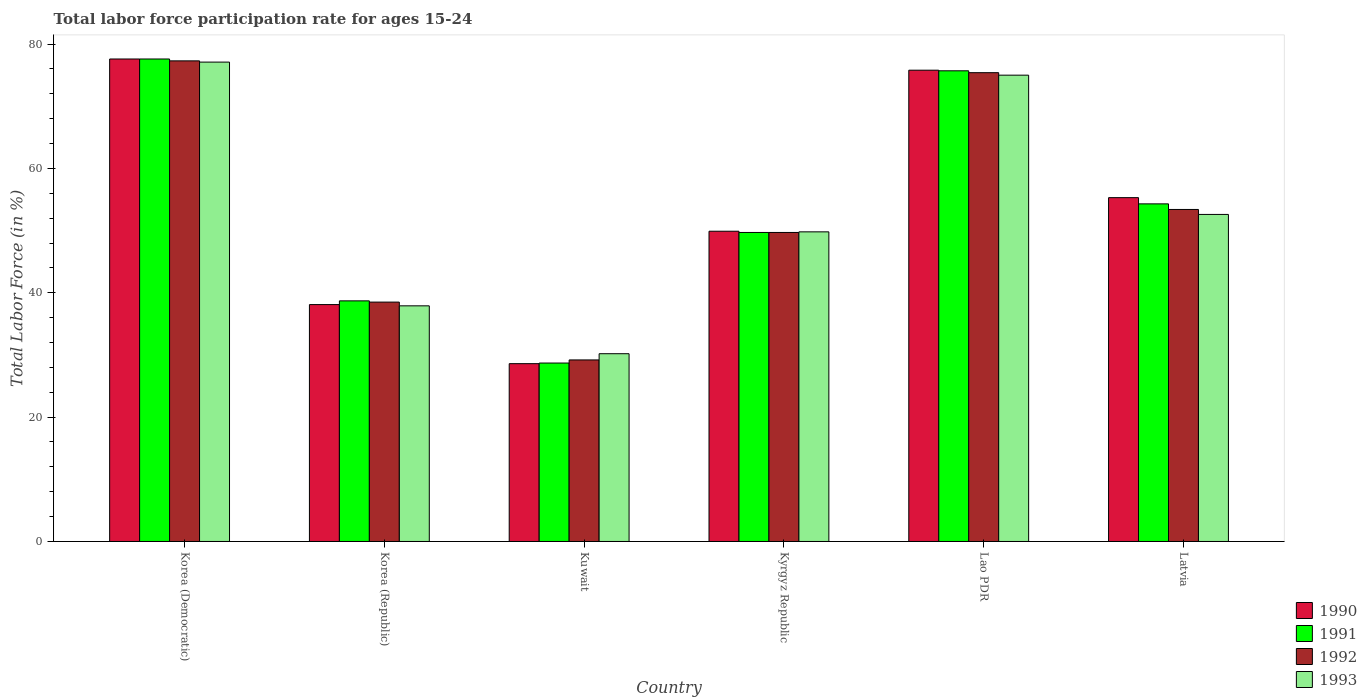How many different coloured bars are there?
Ensure brevity in your answer.  4. How many groups of bars are there?
Provide a succinct answer. 6. What is the label of the 5th group of bars from the left?
Give a very brief answer. Lao PDR. In how many cases, is the number of bars for a given country not equal to the number of legend labels?
Offer a very short reply. 0. What is the labor force participation rate in 1993 in Kuwait?
Give a very brief answer. 30.2. Across all countries, what is the maximum labor force participation rate in 1991?
Offer a very short reply. 77.6. Across all countries, what is the minimum labor force participation rate in 1991?
Provide a short and direct response. 28.7. In which country was the labor force participation rate in 1993 maximum?
Ensure brevity in your answer.  Korea (Democratic). In which country was the labor force participation rate in 1990 minimum?
Your answer should be very brief. Kuwait. What is the total labor force participation rate in 1992 in the graph?
Offer a very short reply. 323.5. What is the difference between the labor force participation rate in 1990 in Kuwait and that in Kyrgyz Republic?
Offer a terse response. -21.3. What is the average labor force participation rate in 1992 per country?
Make the answer very short. 53.92. What is the difference between the labor force participation rate of/in 1993 and labor force participation rate of/in 1991 in Kyrgyz Republic?
Your answer should be very brief. 0.1. In how many countries, is the labor force participation rate in 1993 greater than 20 %?
Keep it short and to the point. 6. What is the ratio of the labor force participation rate in 1991 in Korea (Republic) to that in Latvia?
Make the answer very short. 0.71. What is the difference between the highest and the second highest labor force participation rate in 1992?
Make the answer very short. -22. What is the difference between the highest and the lowest labor force participation rate in 1990?
Your answer should be very brief. 49. In how many countries, is the labor force participation rate in 1990 greater than the average labor force participation rate in 1990 taken over all countries?
Your answer should be compact. 3. Is it the case that in every country, the sum of the labor force participation rate in 1993 and labor force participation rate in 1992 is greater than the sum of labor force participation rate in 1991 and labor force participation rate in 1990?
Offer a terse response. No. What does the 4th bar from the right in Kuwait represents?
Offer a terse response. 1990. How many bars are there?
Your response must be concise. 24. How many countries are there in the graph?
Your response must be concise. 6. Are the values on the major ticks of Y-axis written in scientific E-notation?
Your answer should be compact. No. How many legend labels are there?
Give a very brief answer. 4. How are the legend labels stacked?
Provide a short and direct response. Vertical. What is the title of the graph?
Offer a very short reply. Total labor force participation rate for ages 15-24. Does "1967" appear as one of the legend labels in the graph?
Your answer should be compact. No. What is the label or title of the Y-axis?
Provide a short and direct response. Total Labor Force (in %). What is the Total Labor Force (in %) of 1990 in Korea (Democratic)?
Your response must be concise. 77.6. What is the Total Labor Force (in %) in 1991 in Korea (Democratic)?
Offer a terse response. 77.6. What is the Total Labor Force (in %) of 1992 in Korea (Democratic)?
Offer a very short reply. 77.3. What is the Total Labor Force (in %) in 1993 in Korea (Democratic)?
Ensure brevity in your answer.  77.1. What is the Total Labor Force (in %) of 1990 in Korea (Republic)?
Ensure brevity in your answer.  38.1. What is the Total Labor Force (in %) of 1991 in Korea (Republic)?
Your response must be concise. 38.7. What is the Total Labor Force (in %) of 1992 in Korea (Republic)?
Offer a terse response. 38.5. What is the Total Labor Force (in %) in 1993 in Korea (Republic)?
Offer a very short reply. 37.9. What is the Total Labor Force (in %) of 1990 in Kuwait?
Make the answer very short. 28.6. What is the Total Labor Force (in %) of 1991 in Kuwait?
Your answer should be very brief. 28.7. What is the Total Labor Force (in %) of 1992 in Kuwait?
Offer a terse response. 29.2. What is the Total Labor Force (in %) of 1993 in Kuwait?
Offer a terse response. 30.2. What is the Total Labor Force (in %) of 1990 in Kyrgyz Republic?
Your answer should be compact. 49.9. What is the Total Labor Force (in %) of 1991 in Kyrgyz Republic?
Your answer should be compact. 49.7. What is the Total Labor Force (in %) of 1992 in Kyrgyz Republic?
Provide a short and direct response. 49.7. What is the Total Labor Force (in %) in 1993 in Kyrgyz Republic?
Offer a terse response. 49.8. What is the Total Labor Force (in %) in 1990 in Lao PDR?
Your answer should be compact. 75.8. What is the Total Labor Force (in %) in 1991 in Lao PDR?
Give a very brief answer. 75.7. What is the Total Labor Force (in %) of 1992 in Lao PDR?
Offer a terse response. 75.4. What is the Total Labor Force (in %) of 1990 in Latvia?
Provide a short and direct response. 55.3. What is the Total Labor Force (in %) of 1991 in Latvia?
Make the answer very short. 54.3. What is the Total Labor Force (in %) of 1992 in Latvia?
Ensure brevity in your answer.  53.4. What is the Total Labor Force (in %) in 1993 in Latvia?
Your answer should be very brief. 52.6. Across all countries, what is the maximum Total Labor Force (in %) of 1990?
Your answer should be compact. 77.6. Across all countries, what is the maximum Total Labor Force (in %) in 1991?
Ensure brevity in your answer.  77.6. Across all countries, what is the maximum Total Labor Force (in %) in 1992?
Keep it short and to the point. 77.3. Across all countries, what is the maximum Total Labor Force (in %) in 1993?
Give a very brief answer. 77.1. Across all countries, what is the minimum Total Labor Force (in %) in 1990?
Your answer should be compact. 28.6. Across all countries, what is the minimum Total Labor Force (in %) of 1991?
Ensure brevity in your answer.  28.7. Across all countries, what is the minimum Total Labor Force (in %) of 1992?
Provide a short and direct response. 29.2. Across all countries, what is the minimum Total Labor Force (in %) in 1993?
Ensure brevity in your answer.  30.2. What is the total Total Labor Force (in %) in 1990 in the graph?
Your answer should be compact. 325.3. What is the total Total Labor Force (in %) of 1991 in the graph?
Make the answer very short. 324.7. What is the total Total Labor Force (in %) of 1992 in the graph?
Offer a terse response. 323.5. What is the total Total Labor Force (in %) of 1993 in the graph?
Provide a short and direct response. 322.6. What is the difference between the Total Labor Force (in %) of 1990 in Korea (Democratic) and that in Korea (Republic)?
Your answer should be compact. 39.5. What is the difference between the Total Labor Force (in %) in 1991 in Korea (Democratic) and that in Korea (Republic)?
Offer a terse response. 38.9. What is the difference between the Total Labor Force (in %) of 1992 in Korea (Democratic) and that in Korea (Republic)?
Your answer should be compact. 38.8. What is the difference between the Total Labor Force (in %) in 1993 in Korea (Democratic) and that in Korea (Republic)?
Provide a succinct answer. 39.2. What is the difference between the Total Labor Force (in %) in 1990 in Korea (Democratic) and that in Kuwait?
Your answer should be compact. 49. What is the difference between the Total Labor Force (in %) in 1991 in Korea (Democratic) and that in Kuwait?
Offer a terse response. 48.9. What is the difference between the Total Labor Force (in %) in 1992 in Korea (Democratic) and that in Kuwait?
Your answer should be very brief. 48.1. What is the difference between the Total Labor Force (in %) in 1993 in Korea (Democratic) and that in Kuwait?
Your answer should be very brief. 46.9. What is the difference between the Total Labor Force (in %) of 1990 in Korea (Democratic) and that in Kyrgyz Republic?
Make the answer very short. 27.7. What is the difference between the Total Labor Force (in %) in 1991 in Korea (Democratic) and that in Kyrgyz Republic?
Provide a succinct answer. 27.9. What is the difference between the Total Labor Force (in %) in 1992 in Korea (Democratic) and that in Kyrgyz Republic?
Offer a very short reply. 27.6. What is the difference between the Total Labor Force (in %) of 1993 in Korea (Democratic) and that in Kyrgyz Republic?
Provide a succinct answer. 27.3. What is the difference between the Total Labor Force (in %) of 1990 in Korea (Democratic) and that in Lao PDR?
Make the answer very short. 1.8. What is the difference between the Total Labor Force (in %) in 1992 in Korea (Democratic) and that in Lao PDR?
Offer a very short reply. 1.9. What is the difference between the Total Labor Force (in %) in 1993 in Korea (Democratic) and that in Lao PDR?
Ensure brevity in your answer.  2.1. What is the difference between the Total Labor Force (in %) of 1990 in Korea (Democratic) and that in Latvia?
Keep it short and to the point. 22.3. What is the difference between the Total Labor Force (in %) of 1991 in Korea (Democratic) and that in Latvia?
Your answer should be compact. 23.3. What is the difference between the Total Labor Force (in %) of 1992 in Korea (Democratic) and that in Latvia?
Your answer should be compact. 23.9. What is the difference between the Total Labor Force (in %) in 1992 in Korea (Republic) and that in Kuwait?
Provide a short and direct response. 9.3. What is the difference between the Total Labor Force (in %) in 1991 in Korea (Republic) and that in Kyrgyz Republic?
Your response must be concise. -11. What is the difference between the Total Labor Force (in %) in 1990 in Korea (Republic) and that in Lao PDR?
Provide a succinct answer. -37.7. What is the difference between the Total Labor Force (in %) in 1991 in Korea (Republic) and that in Lao PDR?
Your response must be concise. -37. What is the difference between the Total Labor Force (in %) of 1992 in Korea (Republic) and that in Lao PDR?
Keep it short and to the point. -36.9. What is the difference between the Total Labor Force (in %) of 1993 in Korea (Republic) and that in Lao PDR?
Your answer should be compact. -37.1. What is the difference between the Total Labor Force (in %) in 1990 in Korea (Republic) and that in Latvia?
Ensure brevity in your answer.  -17.2. What is the difference between the Total Labor Force (in %) of 1991 in Korea (Republic) and that in Latvia?
Offer a terse response. -15.6. What is the difference between the Total Labor Force (in %) in 1992 in Korea (Republic) and that in Latvia?
Ensure brevity in your answer.  -14.9. What is the difference between the Total Labor Force (in %) of 1993 in Korea (Republic) and that in Latvia?
Keep it short and to the point. -14.7. What is the difference between the Total Labor Force (in %) in 1990 in Kuwait and that in Kyrgyz Republic?
Provide a succinct answer. -21.3. What is the difference between the Total Labor Force (in %) of 1991 in Kuwait and that in Kyrgyz Republic?
Your answer should be very brief. -21. What is the difference between the Total Labor Force (in %) in 1992 in Kuwait and that in Kyrgyz Republic?
Ensure brevity in your answer.  -20.5. What is the difference between the Total Labor Force (in %) in 1993 in Kuwait and that in Kyrgyz Republic?
Ensure brevity in your answer.  -19.6. What is the difference between the Total Labor Force (in %) in 1990 in Kuwait and that in Lao PDR?
Make the answer very short. -47.2. What is the difference between the Total Labor Force (in %) in 1991 in Kuwait and that in Lao PDR?
Ensure brevity in your answer.  -47. What is the difference between the Total Labor Force (in %) of 1992 in Kuwait and that in Lao PDR?
Provide a succinct answer. -46.2. What is the difference between the Total Labor Force (in %) of 1993 in Kuwait and that in Lao PDR?
Ensure brevity in your answer.  -44.8. What is the difference between the Total Labor Force (in %) in 1990 in Kuwait and that in Latvia?
Offer a terse response. -26.7. What is the difference between the Total Labor Force (in %) of 1991 in Kuwait and that in Latvia?
Keep it short and to the point. -25.6. What is the difference between the Total Labor Force (in %) in 1992 in Kuwait and that in Latvia?
Keep it short and to the point. -24.2. What is the difference between the Total Labor Force (in %) in 1993 in Kuwait and that in Latvia?
Your answer should be very brief. -22.4. What is the difference between the Total Labor Force (in %) in 1990 in Kyrgyz Republic and that in Lao PDR?
Give a very brief answer. -25.9. What is the difference between the Total Labor Force (in %) in 1991 in Kyrgyz Republic and that in Lao PDR?
Offer a terse response. -26. What is the difference between the Total Labor Force (in %) of 1992 in Kyrgyz Republic and that in Lao PDR?
Provide a succinct answer. -25.7. What is the difference between the Total Labor Force (in %) of 1993 in Kyrgyz Republic and that in Lao PDR?
Provide a succinct answer. -25.2. What is the difference between the Total Labor Force (in %) in 1990 in Kyrgyz Republic and that in Latvia?
Your answer should be very brief. -5.4. What is the difference between the Total Labor Force (in %) of 1991 in Kyrgyz Republic and that in Latvia?
Your response must be concise. -4.6. What is the difference between the Total Labor Force (in %) in 1991 in Lao PDR and that in Latvia?
Ensure brevity in your answer.  21.4. What is the difference between the Total Labor Force (in %) in 1992 in Lao PDR and that in Latvia?
Offer a very short reply. 22. What is the difference between the Total Labor Force (in %) of 1993 in Lao PDR and that in Latvia?
Your answer should be compact. 22.4. What is the difference between the Total Labor Force (in %) in 1990 in Korea (Democratic) and the Total Labor Force (in %) in 1991 in Korea (Republic)?
Keep it short and to the point. 38.9. What is the difference between the Total Labor Force (in %) in 1990 in Korea (Democratic) and the Total Labor Force (in %) in 1992 in Korea (Republic)?
Give a very brief answer. 39.1. What is the difference between the Total Labor Force (in %) of 1990 in Korea (Democratic) and the Total Labor Force (in %) of 1993 in Korea (Republic)?
Give a very brief answer. 39.7. What is the difference between the Total Labor Force (in %) of 1991 in Korea (Democratic) and the Total Labor Force (in %) of 1992 in Korea (Republic)?
Your response must be concise. 39.1. What is the difference between the Total Labor Force (in %) of 1991 in Korea (Democratic) and the Total Labor Force (in %) of 1993 in Korea (Republic)?
Offer a terse response. 39.7. What is the difference between the Total Labor Force (in %) in 1992 in Korea (Democratic) and the Total Labor Force (in %) in 1993 in Korea (Republic)?
Give a very brief answer. 39.4. What is the difference between the Total Labor Force (in %) in 1990 in Korea (Democratic) and the Total Labor Force (in %) in 1991 in Kuwait?
Ensure brevity in your answer.  48.9. What is the difference between the Total Labor Force (in %) of 1990 in Korea (Democratic) and the Total Labor Force (in %) of 1992 in Kuwait?
Your response must be concise. 48.4. What is the difference between the Total Labor Force (in %) of 1990 in Korea (Democratic) and the Total Labor Force (in %) of 1993 in Kuwait?
Your response must be concise. 47.4. What is the difference between the Total Labor Force (in %) in 1991 in Korea (Democratic) and the Total Labor Force (in %) in 1992 in Kuwait?
Your answer should be compact. 48.4. What is the difference between the Total Labor Force (in %) in 1991 in Korea (Democratic) and the Total Labor Force (in %) in 1993 in Kuwait?
Make the answer very short. 47.4. What is the difference between the Total Labor Force (in %) in 1992 in Korea (Democratic) and the Total Labor Force (in %) in 1993 in Kuwait?
Provide a short and direct response. 47.1. What is the difference between the Total Labor Force (in %) of 1990 in Korea (Democratic) and the Total Labor Force (in %) of 1991 in Kyrgyz Republic?
Your response must be concise. 27.9. What is the difference between the Total Labor Force (in %) in 1990 in Korea (Democratic) and the Total Labor Force (in %) in 1992 in Kyrgyz Republic?
Give a very brief answer. 27.9. What is the difference between the Total Labor Force (in %) in 1990 in Korea (Democratic) and the Total Labor Force (in %) in 1993 in Kyrgyz Republic?
Give a very brief answer. 27.8. What is the difference between the Total Labor Force (in %) in 1991 in Korea (Democratic) and the Total Labor Force (in %) in 1992 in Kyrgyz Republic?
Give a very brief answer. 27.9. What is the difference between the Total Labor Force (in %) in 1991 in Korea (Democratic) and the Total Labor Force (in %) in 1993 in Kyrgyz Republic?
Offer a terse response. 27.8. What is the difference between the Total Labor Force (in %) of 1990 in Korea (Democratic) and the Total Labor Force (in %) of 1991 in Lao PDR?
Ensure brevity in your answer.  1.9. What is the difference between the Total Labor Force (in %) of 1990 in Korea (Democratic) and the Total Labor Force (in %) of 1993 in Lao PDR?
Provide a short and direct response. 2.6. What is the difference between the Total Labor Force (in %) of 1992 in Korea (Democratic) and the Total Labor Force (in %) of 1993 in Lao PDR?
Offer a terse response. 2.3. What is the difference between the Total Labor Force (in %) of 1990 in Korea (Democratic) and the Total Labor Force (in %) of 1991 in Latvia?
Keep it short and to the point. 23.3. What is the difference between the Total Labor Force (in %) in 1990 in Korea (Democratic) and the Total Labor Force (in %) in 1992 in Latvia?
Ensure brevity in your answer.  24.2. What is the difference between the Total Labor Force (in %) of 1991 in Korea (Democratic) and the Total Labor Force (in %) of 1992 in Latvia?
Your answer should be very brief. 24.2. What is the difference between the Total Labor Force (in %) in 1991 in Korea (Democratic) and the Total Labor Force (in %) in 1993 in Latvia?
Offer a very short reply. 25. What is the difference between the Total Labor Force (in %) in 1992 in Korea (Democratic) and the Total Labor Force (in %) in 1993 in Latvia?
Offer a very short reply. 24.7. What is the difference between the Total Labor Force (in %) in 1990 in Korea (Republic) and the Total Labor Force (in %) in 1993 in Kuwait?
Provide a succinct answer. 7.9. What is the difference between the Total Labor Force (in %) in 1991 in Korea (Republic) and the Total Labor Force (in %) in 1993 in Kuwait?
Your answer should be compact. 8.5. What is the difference between the Total Labor Force (in %) in 1992 in Korea (Republic) and the Total Labor Force (in %) in 1993 in Kuwait?
Your answer should be compact. 8.3. What is the difference between the Total Labor Force (in %) in 1990 in Korea (Republic) and the Total Labor Force (in %) in 1993 in Kyrgyz Republic?
Your answer should be compact. -11.7. What is the difference between the Total Labor Force (in %) of 1991 in Korea (Republic) and the Total Labor Force (in %) of 1992 in Kyrgyz Republic?
Your response must be concise. -11. What is the difference between the Total Labor Force (in %) of 1992 in Korea (Republic) and the Total Labor Force (in %) of 1993 in Kyrgyz Republic?
Make the answer very short. -11.3. What is the difference between the Total Labor Force (in %) in 1990 in Korea (Republic) and the Total Labor Force (in %) in 1991 in Lao PDR?
Offer a very short reply. -37.6. What is the difference between the Total Labor Force (in %) in 1990 in Korea (Republic) and the Total Labor Force (in %) in 1992 in Lao PDR?
Your answer should be compact. -37.3. What is the difference between the Total Labor Force (in %) in 1990 in Korea (Republic) and the Total Labor Force (in %) in 1993 in Lao PDR?
Ensure brevity in your answer.  -36.9. What is the difference between the Total Labor Force (in %) in 1991 in Korea (Republic) and the Total Labor Force (in %) in 1992 in Lao PDR?
Ensure brevity in your answer.  -36.7. What is the difference between the Total Labor Force (in %) in 1991 in Korea (Republic) and the Total Labor Force (in %) in 1993 in Lao PDR?
Your response must be concise. -36.3. What is the difference between the Total Labor Force (in %) in 1992 in Korea (Republic) and the Total Labor Force (in %) in 1993 in Lao PDR?
Offer a terse response. -36.5. What is the difference between the Total Labor Force (in %) of 1990 in Korea (Republic) and the Total Labor Force (in %) of 1991 in Latvia?
Give a very brief answer. -16.2. What is the difference between the Total Labor Force (in %) of 1990 in Korea (Republic) and the Total Labor Force (in %) of 1992 in Latvia?
Your answer should be compact. -15.3. What is the difference between the Total Labor Force (in %) in 1991 in Korea (Republic) and the Total Labor Force (in %) in 1992 in Latvia?
Offer a terse response. -14.7. What is the difference between the Total Labor Force (in %) of 1991 in Korea (Republic) and the Total Labor Force (in %) of 1993 in Latvia?
Provide a short and direct response. -13.9. What is the difference between the Total Labor Force (in %) in 1992 in Korea (Republic) and the Total Labor Force (in %) in 1993 in Latvia?
Your response must be concise. -14.1. What is the difference between the Total Labor Force (in %) of 1990 in Kuwait and the Total Labor Force (in %) of 1991 in Kyrgyz Republic?
Ensure brevity in your answer.  -21.1. What is the difference between the Total Labor Force (in %) of 1990 in Kuwait and the Total Labor Force (in %) of 1992 in Kyrgyz Republic?
Provide a succinct answer. -21.1. What is the difference between the Total Labor Force (in %) in 1990 in Kuwait and the Total Labor Force (in %) in 1993 in Kyrgyz Republic?
Ensure brevity in your answer.  -21.2. What is the difference between the Total Labor Force (in %) in 1991 in Kuwait and the Total Labor Force (in %) in 1993 in Kyrgyz Republic?
Your answer should be very brief. -21.1. What is the difference between the Total Labor Force (in %) in 1992 in Kuwait and the Total Labor Force (in %) in 1993 in Kyrgyz Republic?
Your answer should be compact. -20.6. What is the difference between the Total Labor Force (in %) in 1990 in Kuwait and the Total Labor Force (in %) in 1991 in Lao PDR?
Make the answer very short. -47.1. What is the difference between the Total Labor Force (in %) of 1990 in Kuwait and the Total Labor Force (in %) of 1992 in Lao PDR?
Make the answer very short. -46.8. What is the difference between the Total Labor Force (in %) in 1990 in Kuwait and the Total Labor Force (in %) in 1993 in Lao PDR?
Your answer should be very brief. -46.4. What is the difference between the Total Labor Force (in %) of 1991 in Kuwait and the Total Labor Force (in %) of 1992 in Lao PDR?
Give a very brief answer. -46.7. What is the difference between the Total Labor Force (in %) in 1991 in Kuwait and the Total Labor Force (in %) in 1993 in Lao PDR?
Your response must be concise. -46.3. What is the difference between the Total Labor Force (in %) of 1992 in Kuwait and the Total Labor Force (in %) of 1993 in Lao PDR?
Keep it short and to the point. -45.8. What is the difference between the Total Labor Force (in %) of 1990 in Kuwait and the Total Labor Force (in %) of 1991 in Latvia?
Your answer should be compact. -25.7. What is the difference between the Total Labor Force (in %) of 1990 in Kuwait and the Total Labor Force (in %) of 1992 in Latvia?
Keep it short and to the point. -24.8. What is the difference between the Total Labor Force (in %) in 1991 in Kuwait and the Total Labor Force (in %) in 1992 in Latvia?
Provide a succinct answer. -24.7. What is the difference between the Total Labor Force (in %) in 1991 in Kuwait and the Total Labor Force (in %) in 1993 in Latvia?
Your response must be concise. -23.9. What is the difference between the Total Labor Force (in %) of 1992 in Kuwait and the Total Labor Force (in %) of 1993 in Latvia?
Your answer should be compact. -23.4. What is the difference between the Total Labor Force (in %) in 1990 in Kyrgyz Republic and the Total Labor Force (in %) in 1991 in Lao PDR?
Ensure brevity in your answer.  -25.8. What is the difference between the Total Labor Force (in %) of 1990 in Kyrgyz Republic and the Total Labor Force (in %) of 1992 in Lao PDR?
Your answer should be compact. -25.5. What is the difference between the Total Labor Force (in %) of 1990 in Kyrgyz Republic and the Total Labor Force (in %) of 1993 in Lao PDR?
Provide a short and direct response. -25.1. What is the difference between the Total Labor Force (in %) of 1991 in Kyrgyz Republic and the Total Labor Force (in %) of 1992 in Lao PDR?
Your answer should be very brief. -25.7. What is the difference between the Total Labor Force (in %) of 1991 in Kyrgyz Republic and the Total Labor Force (in %) of 1993 in Lao PDR?
Give a very brief answer. -25.3. What is the difference between the Total Labor Force (in %) of 1992 in Kyrgyz Republic and the Total Labor Force (in %) of 1993 in Lao PDR?
Your answer should be very brief. -25.3. What is the difference between the Total Labor Force (in %) in 1990 in Kyrgyz Republic and the Total Labor Force (in %) in 1993 in Latvia?
Your answer should be compact. -2.7. What is the difference between the Total Labor Force (in %) in 1991 in Kyrgyz Republic and the Total Labor Force (in %) in 1993 in Latvia?
Keep it short and to the point. -2.9. What is the difference between the Total Labor Force (in %) in 1992 in Kyrgyz Republic and the Total Labor Force (in %) in 1993 in Latvia?
Your answer should be very brief. -2.9. What is the difference between the Total Labor Force (in %) of 1990 in Lao PDR and the Total Labor Force (in %) of 1992 in Latvia?
Your answer should be very brief. 22.4. What is the difference between the Total Labor Force (in %) of 1990 in Lao PDR and the Total Labor Force (in %) of 1993 in Latvia?
Give a very brief answer. 23.2. What is the difference between the Total Labor Force (in %) of 1991 in Lao PDR and the Total Labor Force (in %) of 1992 in Latvia?
Keep it short and to the point. 22.3. What is the difference between the Total Labor Force (in %) in 1991 in Lao PDR and the Total Labor Force (in %) in 1993 in Latvia?
Offer a very short reply. 23.1. What is the difference between the Total Labor Force (in %) of 1992 in Lao PDR and the Total Labor Force (in %) of 1993 in Latvia?
Offer a very short reply. 22.8. What is the average Total Labor Force (in %) in 1990 per country?
Offer a terse response. 54.22. What is the average Total Labor Force (in %) of 1991 per country?
Keep it short and to the point. 54.12. What is the average Total Labor Force (in %) of 1992 per country?
Your answer should be very brief. 53.92. What is the average Total Labor Force (in %) of 1993 per country?
Provide a short and direct response. 53.77. What is the difference between the Total Labor Force (in %) of 1990 and Total Labor Force (in %) of 1991 in Korea (Democratic)?
Offer a terse response. 0. What is the difference between the Total Labor Force (in %) of 1990 and Total Labor Force (in %) of 1993 in Korea (Democratic)?
Offer a very short reply. 0.5. What is the difference between the Total Labor Force (in %) in 1991 and Total Labor Force (in %) in 1992 in Korea (Democratic)?
Your response must be concise. 0.3. What is the difference between the Total Labor Force (in %) of 1991 and Total Labor Force (in %) of 1993 in Korea (Democratic)?
Give a very brief answer. 0.5. What is the difference between the Total Labor Force (in %) in 1992 and Total Labor Force (in %) in 1993 in Korea (Democratic)?
Offer a terse response. 0.2. What is the difference between the Total Labor Force (in %) in 1990 and Total Labor Force (in %) in 1992 in Korea (Republic)?
Offer a very short reply. -0.4. What is the difference between the Total Labor Force (in %) of 1990 and Total Labor Force (in %) of 1993 in Korea (Republic)?
Provide a short and direct response. 0.2. What is the difference between the Total Labor Force (in %) of 1991 and Total Labor Force (in %) of 1992 in Korea (Republic)?
Keep it short and to the point. 0.2. What is the difference between the Total Labor Force (in %) in 1990 and Total Labor Force (in %) in 1991 in Kuwait?
Provide a short and direct response. -0.1. What is the difference between the Total Labor Force (in %) of 1991 and Total Labor Force (in %) of 1993 in Kuwait?
Keep it short and to the point. -1.5. What is the difference between the Total Labor Force (in %) in 1992 and Total Labor Force (in %) in 1993 in Kuwait?
Make the answer very short. -1. What is the difference between the Total Labor Force (in %) of 1992 and Total Labor Force (in %) of 1993 in Kyrgyz Republic?
Provide a succinct answer. -0.1. What is the difference between the Total Labor Force (in %) in 1990 and Total Labor Force (in %) in 1993 in Lao PDR?
Your answer should be very brief. 0.8. What is the difference between the Total Labor Force (in %) in 1991 and Total Labor Force (in %) in 1992 in Lao PDR?
Your answer should be very brief. 0.3. What is the difference between the Total Labor Force (in %) in 1991 and Total Labor Force (in %) in 1993 in Lao PDR?
Offer a very short reply. 0.7. What is the difference between the Total Labor Force (in %) in 1992 and Total Labor Force (in %) in 1993 in Lao PDR?
Offer a terse response. 0.4. What is the difference between the Total Labor Force (in %) of 1990 and Total Labor Force (in %) of 1991 in Latvia?
Provide a succinct answer. 1. What is the difference between the Total Labor Force (in %) in 1990 and Total Labor Force (in %) in 1992 in Latvia?
Offer a very short reply. 1.9. What is the difference between the Total Labor Force (in %) in 1991 and Total Labor Force (in %) in 1993 in Latvia?
Offer a terse response. 1.7. What is the ratio of the Total Labor Force (in %) in 1990 in Korea (Democratic) to that in Korea (Republic)?
Offer a very short reply. 2.04. What is the ratio of the Total Labor Force (in %) of 1991 in Korea (Democratic) to that in Korea (Republic)?
Keep it short and to the point. 2.01. What is the ratio of the Total Labor Force (in %) in 1992 in Korea (Democratic) to that in Korea (Republic)?
Your answer should be very brief. 2.01. What is the ratio of the Total Labor Force (in %) in 1993 in Korea (Democratic) to that in Korea (Republic)?
Your answer should be compact. 2.03. What is the ratio of the Total Labor Force (in %) of 1990 in Korea (Democratic) to that in Kuwait?
Your answer should be compact. 2.71. What is the ratio of the Total Labor Force (in %) of 1991 in Korea (Democratic) to that in Kuwait?
Your response must be concise. 2.7. What is the ratio of the Total Labor Force (in %) in 1992 in Korea (Democratic) to that in Kuwait?
Offer a very short reply. 2.65. What is the ratio of the Total Labor Force (in %) in 1993 in Korea (Democratic) to that in Kuwait?
Provide a succinct answer. 2.55. What is the ratio of the Total Labor Force (in %) in 1990 in Korea (Democratic) to that in Kyrgyz Republic?
Your answer should be very brief. 1.56. What is the ratio of the Total Labor Force (in %) in 1991 in Korea (Democratic) to that in Kyrgyz Republic?
Make the answer very short. 1.56. What is the ratio of the Total Labor Force (in %) of 1992 in Korea (Democratic) to that in Kyrgyz Republic?
Ensure brevity in your answer.  1.56. What is the ratio of the Total Labor Force (in %) of 1993 in Korea (Democratic) to that in Kyrgyz Republic?
Ensure brevity in your answer.  1.55. What is the ratio of the Total Labor Force (in %) in 1990 in Korea (Democratic) to that in Lao PDR?
Your response must be concise. 1.02. What is the ratio of the Total Labor Force (in %) in 1991 in Korea (Democratic) to that in Lao PDR?
Give a very brief answer. 1.03. What is the ratio of the Total Labor Force (in %) in 1992 in Korea (Democratic) to that in Lao PDR?
Your answer should be compact. 1.03. What is the ratio of the Total Labor Force (in %) of 1993 in Korea (Democratic) to that in Lao PDR?
Your response must be concise. 1.03. What is the ratio of the Total Labor Force (in %) in 1990 in Korea (Democratic) to that in Latvia?
Offer a very short reply. 1.4. What is the ratio of the Total Labor Force (in %) of 1991 in Korea (Democratic) to that in Latvia?
Your response must be concise. 1.43. What is the ratio of the Total Labor Force (in %) in 1992 in Korea (Democratic) to that in Latvia?
Ensure brevity in your answer.  1.45. What is the ratio of the Total Labor Force (in %) of 1993 in Korea (Democratic) to that in Latvia?
Keep it short and to the point. 1.47. What is the ratio of the Total Labor Force (in %) of 1990 in Korea (Republic) to that in Kuwait?
Keep it short and to the point. 1.33. What is the ratio of the Total Labor Force (in %) of 1991 in Korea (Republic) to that in Kuwait?
Provide a succinct answer. 1.35. What is the ratio of the Total Labor Force (in %) of 1992 in Korea (Republic) to that in Kuwait?
Your response must be concise. 1.32. What is the ratio of the Total Labor Force (in %) in 1993 in Korea (Republic) to that in Kuwait?
Provide a short and direct response. 1.25. What is the ratio of the Total Labor Force (in %) in 1990 in Korea (Republic) to that in Kyrgyz Republic?
Your answer should be very brief. 0.76. What is the ratio of the Total Labor Force (in %) in 1991 in Korea (Republic) to that in Kyrgyz Republic?
Give a very brief answer. 0.78. What is the ratio of the Total Labor Force (in %) in 1992 in Korea (Republic) to that in Kyrgyz Republic?
Provide a succinct answer. 0.77. What is the ratio of the Total Labor Force (in %) of 1993 in Korea (Republic) to that in Kyrgyz Republic?
Give a very brief answer. 0.76. What is the ratio of the Total Labor Force (in %) in 1990 in Korea (Republic) to that in Lao PDR?
Keep it short and to the point. 0.5. What is the ratio of the Total Labor Force (in %) of 1991 in Korea (Republic) to that in Lao PDR?
Offer a very short reply. 0.51. What is the ratio of the Total Labor Force (in %) in 1992 in Korea (Republic) to that in Lao PDR?
Your response must be concise. 0.51. What is the ratio of the Total Labor Force (in %) of 1993 in Korea (Republic) to that in Lao PDR?
Provide a succinct answer. 0.51. What is the ratio of the Total Labor Force (in %) of 1990 in Korea (Republic) to that in Latvia?
Your response must be concise. 0.69. What is the ratio of the Total Labor Force (in %) in 1991 in Korea (Republic) to that in Latvia?
Offer a very short reply. 0.71. What is the ratio of the Total Labor Force (in %) in 1992 in Korea (Republic) to that in Latvia?
Keep it short and to the point. 0.72. What is the ratio of the Total Labor Force (in %) of 1993 in Korea (Republic) to that in Latvia?
Your answer should be compact. 0.72. What is the ratio of the Total Labor Force (in %) of 1990 in Kuwait to that in Kyrgyz Republic?
Ensure brevity in your answer.  0.57. What is the ratio of the Total Labor Force (in %) in 1991 in Kuwait to that in Kyrgyz Republic?
Keep it short and to the point. 0.58. What is the ratio of the Total Labor Force (in %) in 1992 in Kuwait to that in Kyrgyz Republic?
Your answer should be compact. 0.59. What is the ratio of the Total Labor Force (in %) in 1993 in Kuwait to that in Kyrgyz Republic?
Keep it short and to the point. 0.61. What is the ratio of the Total Labor Force (in %) in 1990 in Kuwait to that in Lao PDR?
Give a very brief answer. 0.38. What is the ratio of the Total Labor Force (in %) of 1991 in Kuwait to that in Lao PDR?
Give a very brief answer. 0.38. What is the ratio of the Total Labor Force (in %) in 1992 in Kuwait to that in Lao PDR?
Keep it short and to the point. 0.39. What is the ratio of the Total Labor Force (in %) of 1993 in Kuwait to that in Lao PDR?
Ensure brevity in your answer.  0.4. What is the ratio of the Total Labor Force (in %) in 1990 in Kuwait to that in Latvia?
Your answer should be compact. 0.52. What is the ratio of the Total Labor Force (in %) in 1991 in Kuwait to that in Latvia?
Give a very brief answer. 0.53. What is the ratio of the Total Labor Force (in %) in 1992 in Kuwait to that in Latvia?
Your answer should be very brief. 0.55. What is the ratio of the Total Labor Force (in %) of 1993 in Kuwait to that in Latvia?
Give a very brief answer. 0.57. What is the ratio of the Total Labor Force (in %) of 1990 in Kyrgyz Republic to that in Lao PDR?
Your response must be concise. 0.66. What is the ratio of the Total Labor Force (in %) of 1991 in Kyrgyz Republic to that in Lao PDR?
Offer a terse response. 0.66. What is the ratio of the Total Labor Force (in %) in 1992 in Kyrgyz Republic to that in Lao PDR?
Your answer should be compact. 0.66. What is the ratio of the Total Labor Force (in %) in 1993 in Kyrgyz Republic to that in Lao PDR?
Offer a terse response. 0.66. What is the ratio of the Total Labor Force (in %) in 1990 in Kyrgyz Republic to that in Latvia?
Keep it short and to the point. 0.9. What is the ratio of the Total Labor Force (in %) of 1991 in Kyrgyz Republic to that in Latvia?
Your answer should be very brief. 0.92. What is the ratio of the Total Labor Force (in %) in 1992 in Kyrgyz Republic to that in Latvia?
Offer a very short reply. 0.93. What is the ratio of the Total Labor Force (in %) in 1993 in Kyrgyz Republic to that in Latvia?
Give a very brief answer. 0.95. What is the ratio of the Total Labor Force (in %) in 1990 in Lao PDR to that in Latvia?
Your response must be concise. 1.37. What is the ratio of the Total Labor Force (in %) in 1991 in Lao PDR to that in Latvia?
Provide a succinct answer. 1.39. What is the ratio of the Total Labor Force (in %) of 1992 in Lao PDR to that in Latvia?
Your answer should be very brief. 1.41. What is the ratio of the Total Labor Force (in %) in 1993 in Lao PDR to that in Latvia?
Ensure brevity in your answer.  1.43. What is the difference between the highest and the second highest Total Labor Force (in %) in 1991?
Provide a succinct answer. 1.9. What is the difference between the highest and the second highest Total Labor Force (in %) in 1992?
Offer a very short reply. 1.9. What is the difference between the highest and the lowest Total Labor Force (in %) in 1991?
Keep it short and to the point. 48.9. What is the difference between the highest and the lowest Total Labor Force (in %) of 1992?
Give a very brief answer. 48.1. What is the difference between the highest and the lowest Total Labor Force (in %) in 1993?
Offer a terse response. 46.9. 